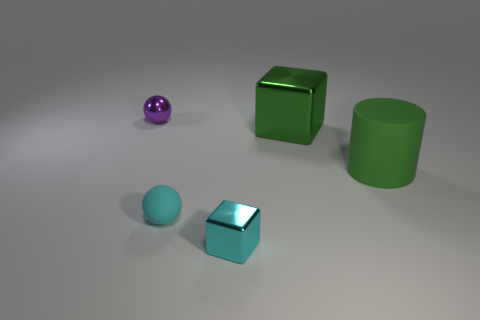Add 1 matte cylinders. How many objects exist? 6 Subtract all spheres. How many objects are left? 3 Add 2 green rubber cylinders. How many green rubber cylinders are left? 3 Add 4 small purple metal spheres. How many small purple metal spheres exist? 5 Subtract 0 blue cubes. How many objects are left? 5 Subtract all blue blocks. Subtract all cyan cylinders. How many blocks are left? 2 Subtract all matte cylinders. Subtract all brown rubber things. How many objects are left? 4 